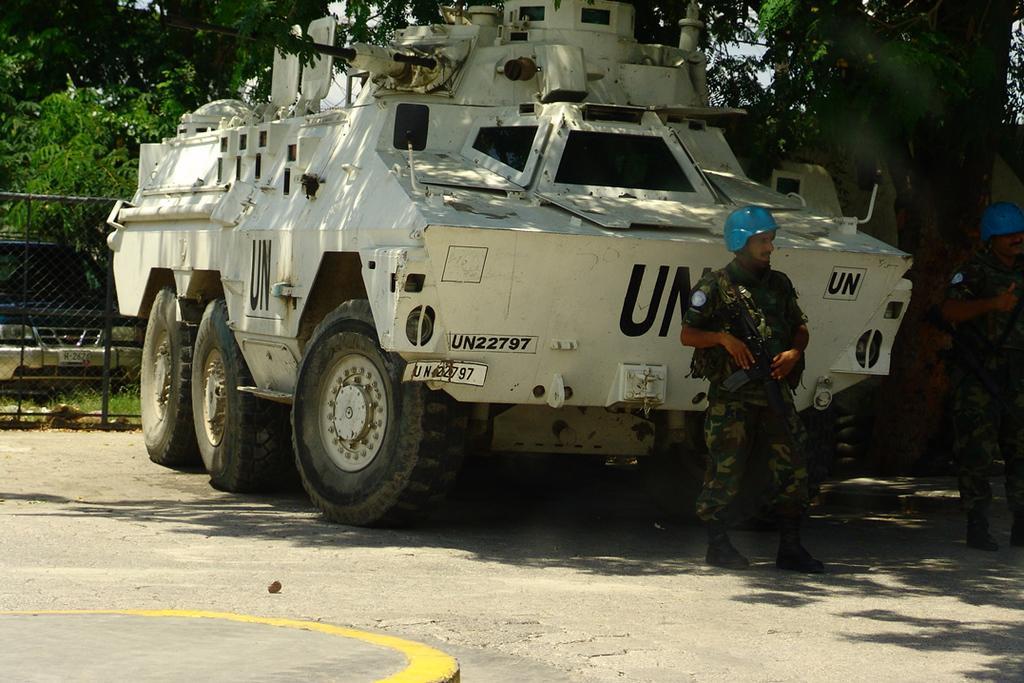How would you summarize this image in a sentence or two? In this image we can see two persons wearing uniform and standing and there is a vehicle on the road. We can see the fence on the left side of the image and behind there is a car and we can see some trees in the background. 